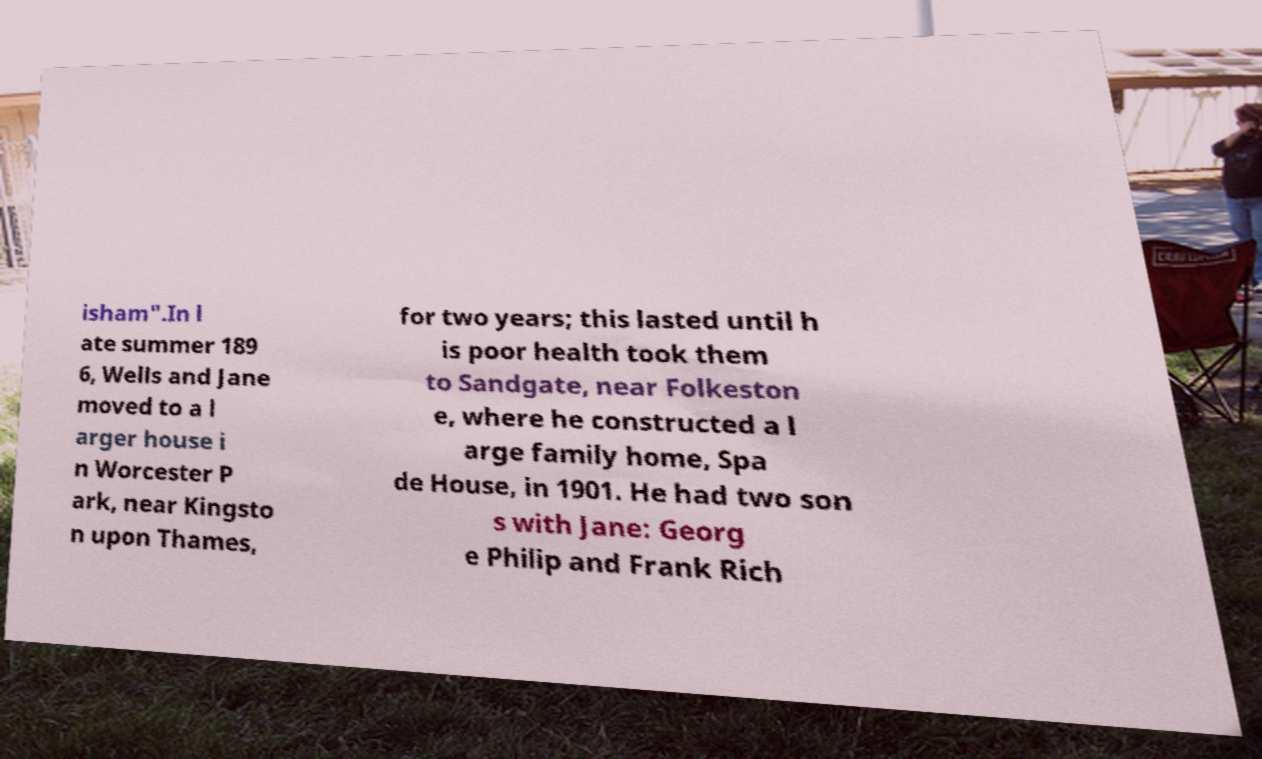Please read and relay the text visible in this image. What does it say? isham".In l ate summer 189 6, Wells and Jane moved to a l arger house i n Worcester P ark, near Kingsto n upon Thames, for two years; this lasted until h is poor health took them to Sandgate, near Folkeston e, where he constructed a l arge family home, Spa de House, in 1901. He had two son s with Jane: Georg e Philip and Frank Rich 